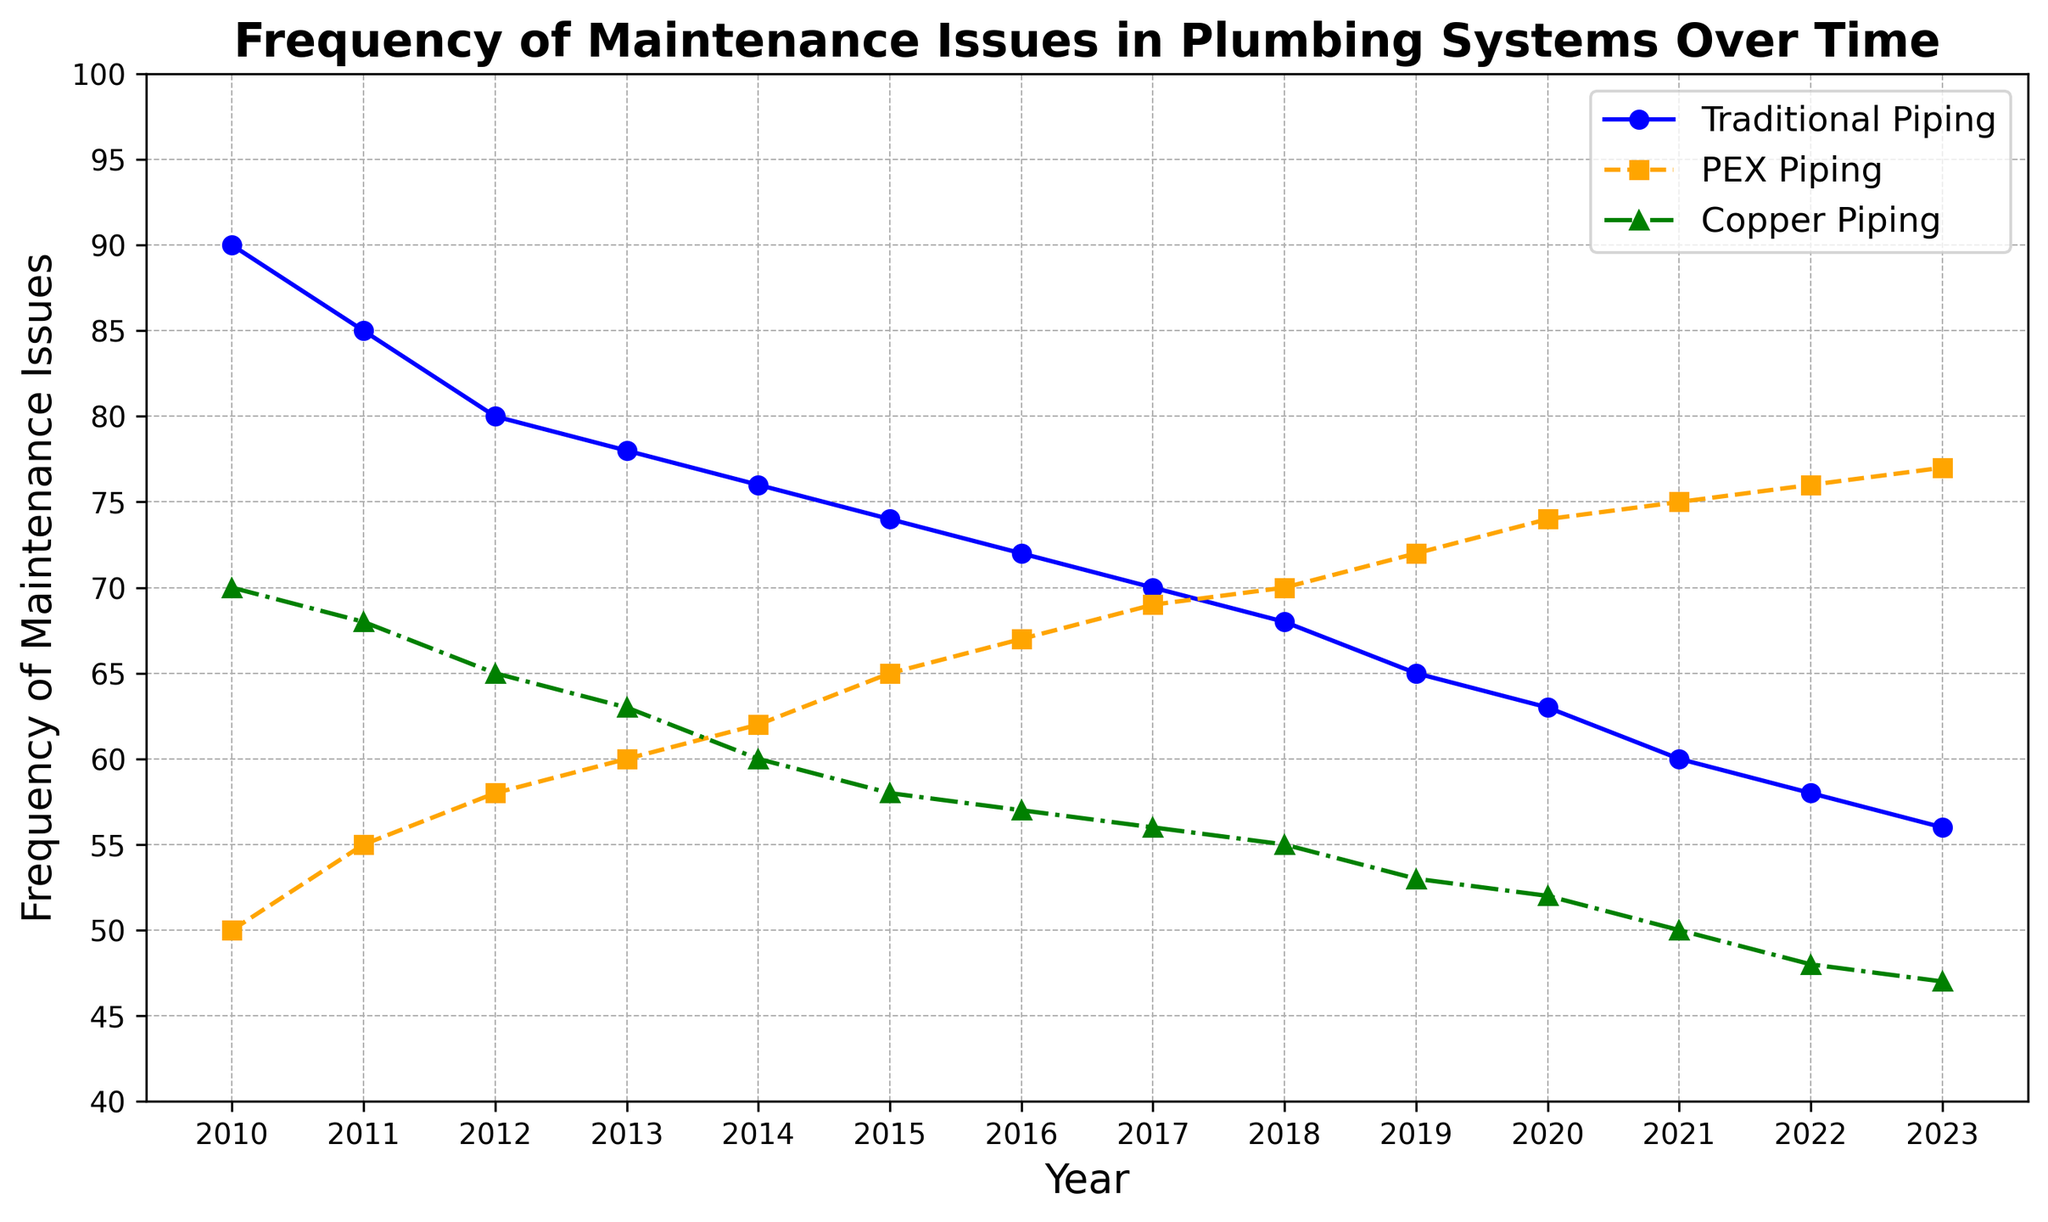Which type of piping had the most maintenance issues in 2020? Identify the year 2020 on the x-axis. Look at the corresponding y-values for each of the three piping types. Traditional Piping has the highest value.
Answer: Traditional Piping How did the frequency of maintenance issues for Copper Piping change from 2014 to 2018? Find the y-values for Copper Piping in 2014 and 2018. Subtract the 2018 value (55) from the 2014 value (60). Calculate 60 - 55 = 5. The frequency decreased by 5.
Answer: Decreased by 5 What is the difference in maintenance issues between Traditional Piping and PEX Piping in 2022? Locate the values for both piping types in 2022. Traditional Piping has 58 and PEX Piping has 76. Calculate 76 - 58 = 18.
Answer: 18 Which piping type shows a consistent decreasing trend in maintenance issues over the years? By looking at the trend lines for all three piping types, Traditional Piping consistently decreases every year.
Answer: Traditional Piping By how much did the frequency of maintenance issues for PEX Piping increase from 2010 to 2023? Find the y-values for PEX Piping in 2010 (50) and 2023 (77). Subtract the 2010 value from the 2023 value. 77 - 50 = 27.
Answer: Increased by 27 In which year did PEX Piping surpass Copper Piping in terms of maintenance issues? Scan the lines to identify the point where the value for PEX Piping becomes greater than that of Copper Piping. This happens between 2015 and 2016. Verify that in 2016, PEX is 67 and Copper is 57.
Answer: 2016 Comparing 2019 with 2023, which type of piping saw the largest overall decrease in maintenance issues? Find the values for each piping type in both years. Calculate the difference for each:
Traditional: 65 - 56 = 9
PEX: 72 - 77 = -5
Copper: 53 - 47 = 6
The largest decrease in absolute value is for Traditional Piping (9).
Answer: Traditional Piping What is the average number of maintenance issues for Copper Piping over the period 2010-2023? Sum all the values for Copper Piping from 2010 to 2023 and divide by the number of years:
(70 + 68 + 65 + 63 + 60 + 58 + 57 + 56 + 55 + 53 + 52 + 50 + 48 + 47) / 14 = 700 / 14 = 50
Answer: 50 What can be observed about the maintenance issues trend for PEX Piping over the years? By analyzing the trend line for PEX Piping, it shows an increasing trend from 2010 (50) to 2023 (77) over all observed years.
Answer: Increasing trend Between which consecutive years did Traditional Piping see the biggest drop in maintenance issues? Compare the drop in values between each pair of consecutive years for Traditional Piping. The biggest drop is between 2012 (80) and 2013 (78), resulting in a drop of 2.
Answer: 2012-2013 